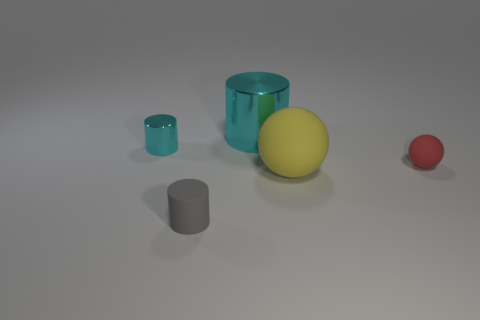Is there a big shiny cylinder that has the same color as the small sphere?
Ensure brevity in your answer.  No. There is a cylinder behind the small cyan cylinder; is it the same color as the small cylinder behind the big yellow rubber thing?
Provide a succinct answer. Yes. There is a gray matte object; what shape is it?
Keep it short and to the point. Cylinder. How many balls are in front of the small metal cylinder?
Provide a succinct answer. 2. What number of big balls are the same material as the yellow thing?
Your response must be concise. 0. Is the cyan cylinder that is right of the small gray object made of the same material as the small cyan object?
Keep it short and to the point. Yes. Are there any small gray matte blocks?
Provide a succinct answer. No. There is a thing that is in front of the red ball and on the right side of the large metallic object; what is its size?
Your response must be concise. Large. Is the number of small cyan cylinders to the left of the small rubber cylinder greater than the number of gray rubber things that are behind the small ball?
Your answer should be very brief. Yes. There is another cylinder that is the same color as the big cylinder; what size is it?
Your response must be concise. Small. 